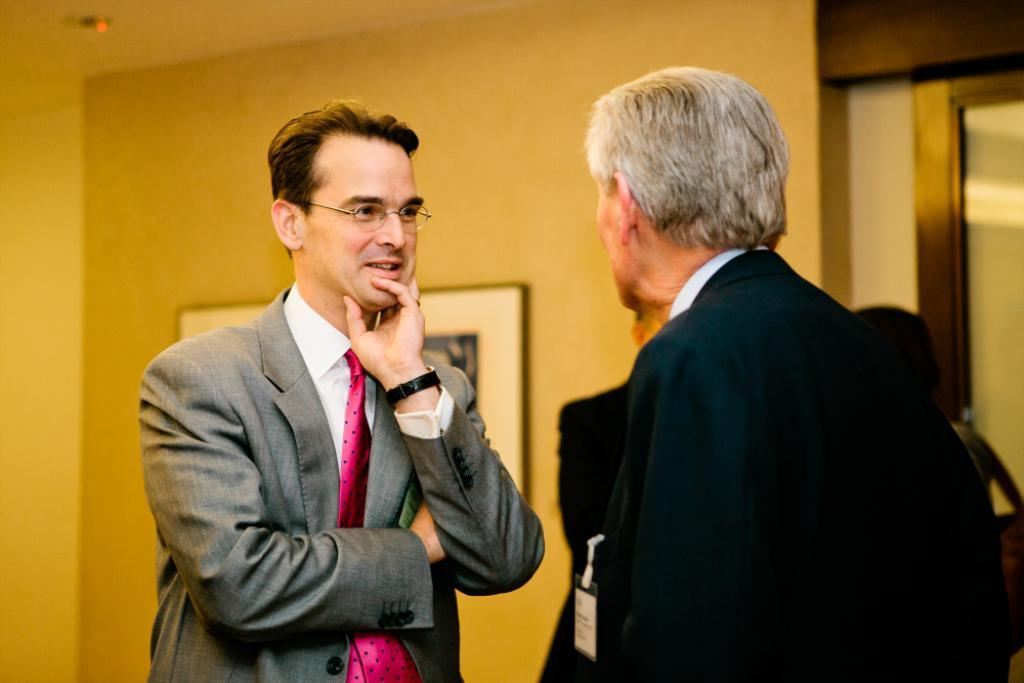What are the main subjects in the image? There are persons standing in the center of the image. What can be seen in the background of the image? There is a wall, a photo frame, and a door in the background of the image. What is visible at the top of the image? Light is visible at the top of the image, and there is a roof. What type of throne is present in the image? There is no throne present in the image. What force is being exerted by the persons in the image? The image does not provide information about any force being exerted by the persons. 